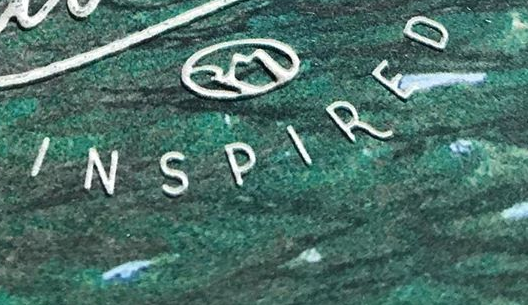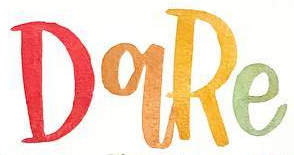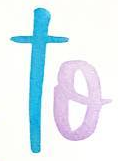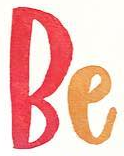Read the text content from these images in order, separated by a semicolon. INSPIRED; DqRe; to; Be 